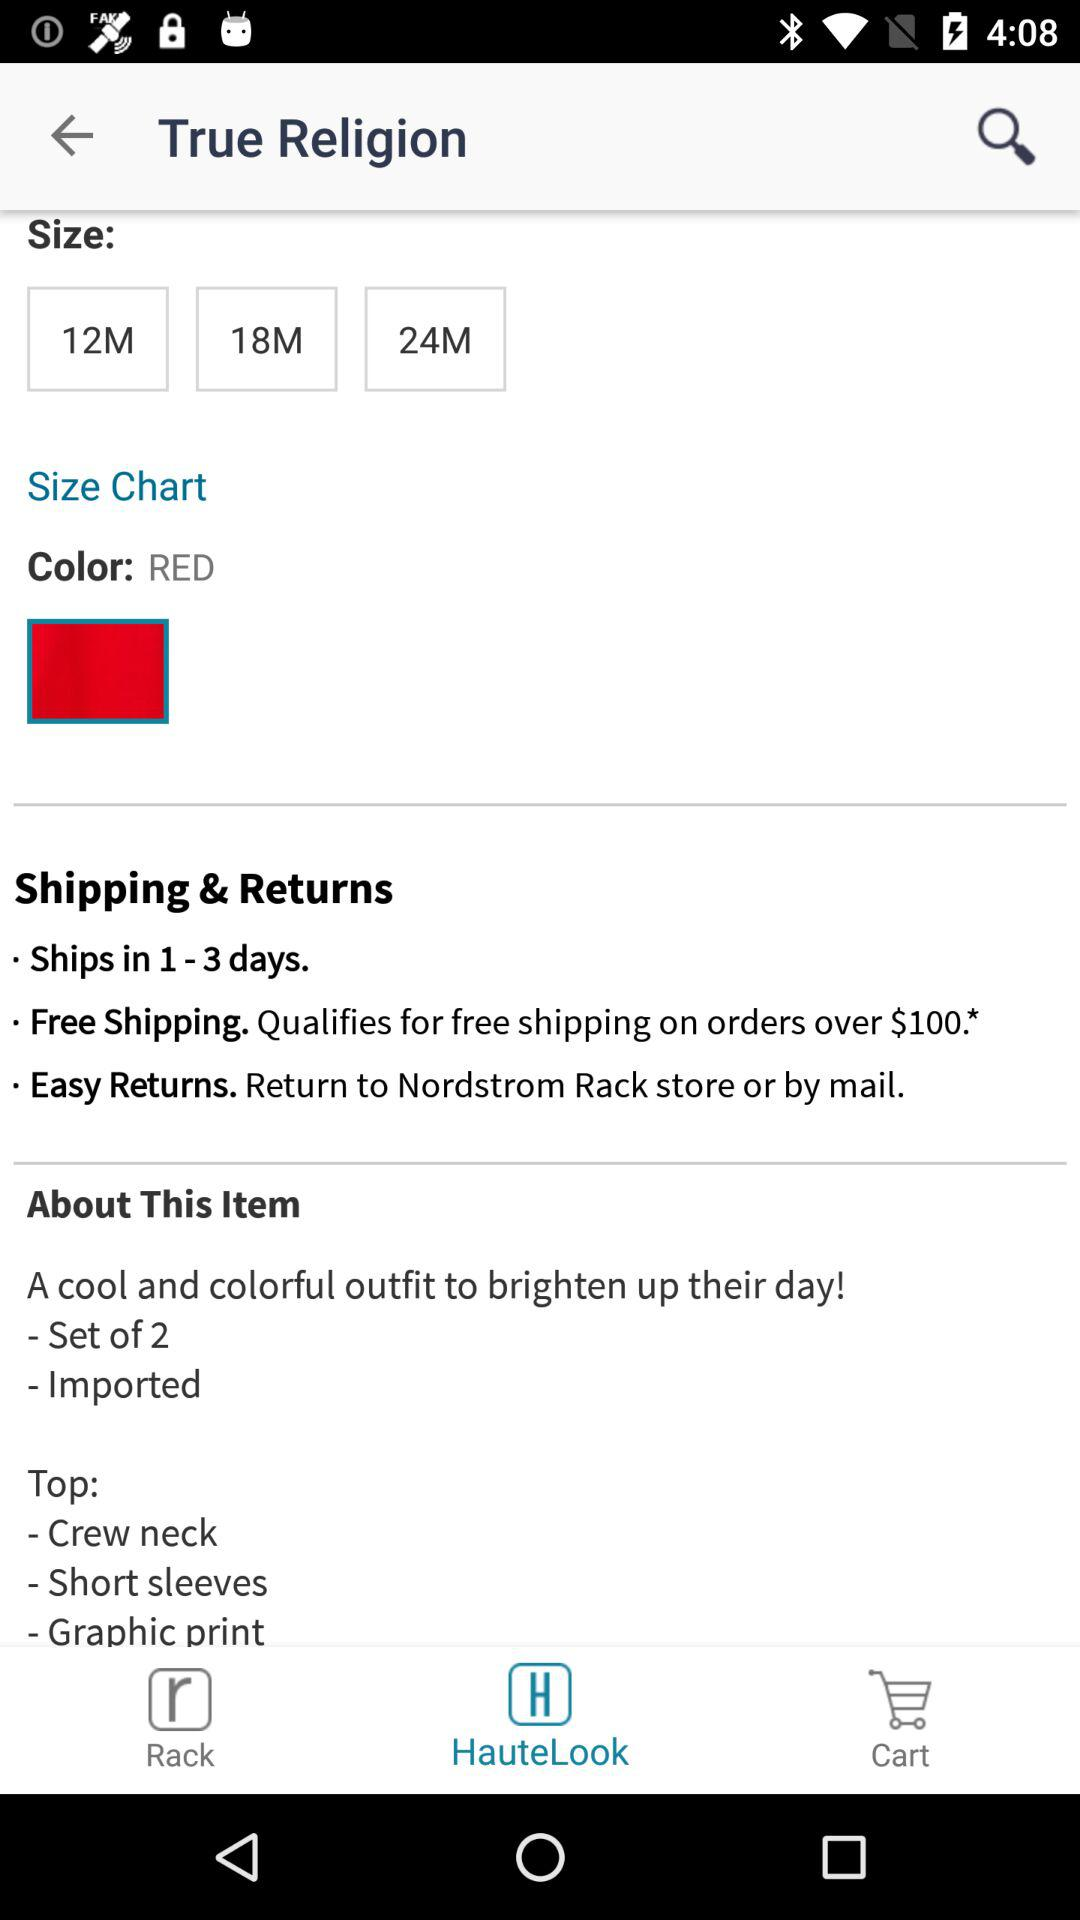What are the available sizes? The available sizes are 12M, 18M and 24M. 